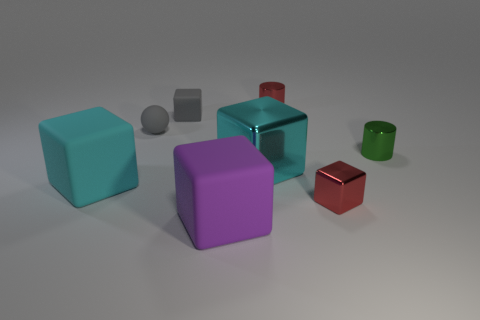How many other things are there of the same shape as the large purple rubber object?
Provide a succinct answer. 4. Is the number of objects that are on the right side of the purple rubber thing greater than the number of blue matte spheres?
Offer a very short reply. Yes. There is a block in front of the red block; what is its color?
Offer a very short reply. Purple. There is a cube that is the same color as the large metallic thing; what size is it?
Ensure brevity in your answer.  Large. What number of rubber objects are either gray cubes or purple cubes?
Your response must be concise. 2. Is there a metal object that is in front of the red metal object that is behind the red thing in front of the rubber sphere?
Provide a succinct answer. Yes. There is a large cyan metal block; what number of big blocks are on the right side of it?
Your answer should be compact. 0. There is a cylinder that is the same color as the small metal block; what material is it?
Ensure brevity in your answer.  Metal. What number of large objects are either cyan matte objects or green cylinders?
Your response must be concise. 1. What shape is the big object that is on the left side of the small gray block?
Offer a terse response. Cube. 